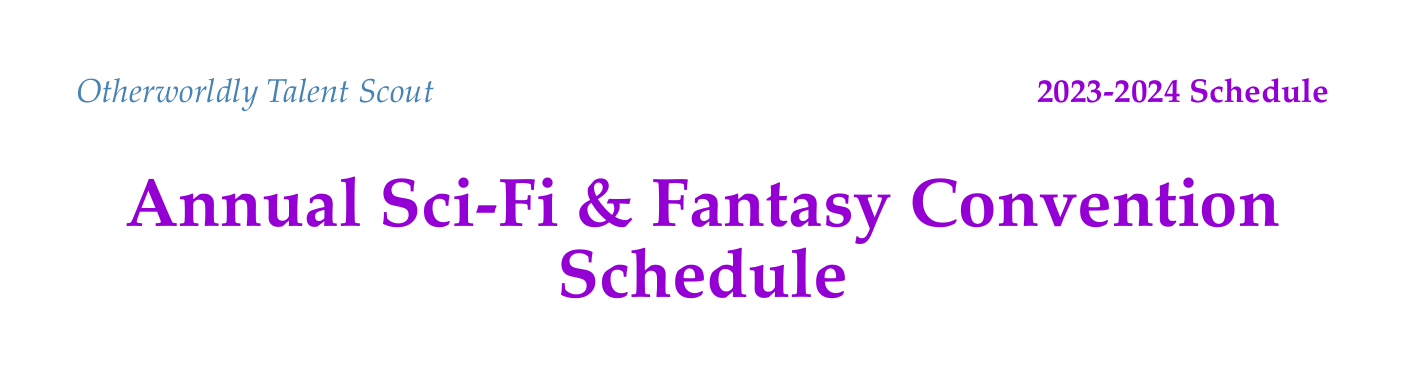What is the date range for WorldCon? The date range for WorldCon is specified in the document as August 15-19, 2023.
Answer: August 15-19, 2023 Where is New York Comic Con located? The location of New York Comic Con is mentioned in the document as New York City, USA.
Answer: New York City, USA What is one highlight of the London Book Fair? The document lists the highlights for the London Book Fair, one of which is 'The Evolution of Otherworldly Beings in Literature'.
Answer: The Evolution of Otherworldly Beings in Literature Which convention features a workshop on crafting alien perspectives? The document indicates that the workshop 'Crafting Unique Alien Perspectives' is a highlight of New York Comic Con.
Answer: New York Comic Con How many conventions are scheduled in 2024? The document lists three conventions with dates in 2024: Emerald City Comic Con, London Book Fair, and Dragon Con.
Answer: Three What type of event is scheduled after the Frankfurt Book Fair? The document does not specify an event immediately after the Frankfurt Book Fair; it focuses on the highlights within the fair.
Answer: None What kind of opportunities does the networking section highlight? The networking opportunities include various event types, focusing on author-agent interactions, indicated in the document.
Answer: Author-agent mixers What task is mentioned for post-convention follow-up? The document includes a variety of tasks under post-convention follow-up, one being 'Send personalized emails to promising new authors.'
Answer: Send personalized emails to promising new authors 